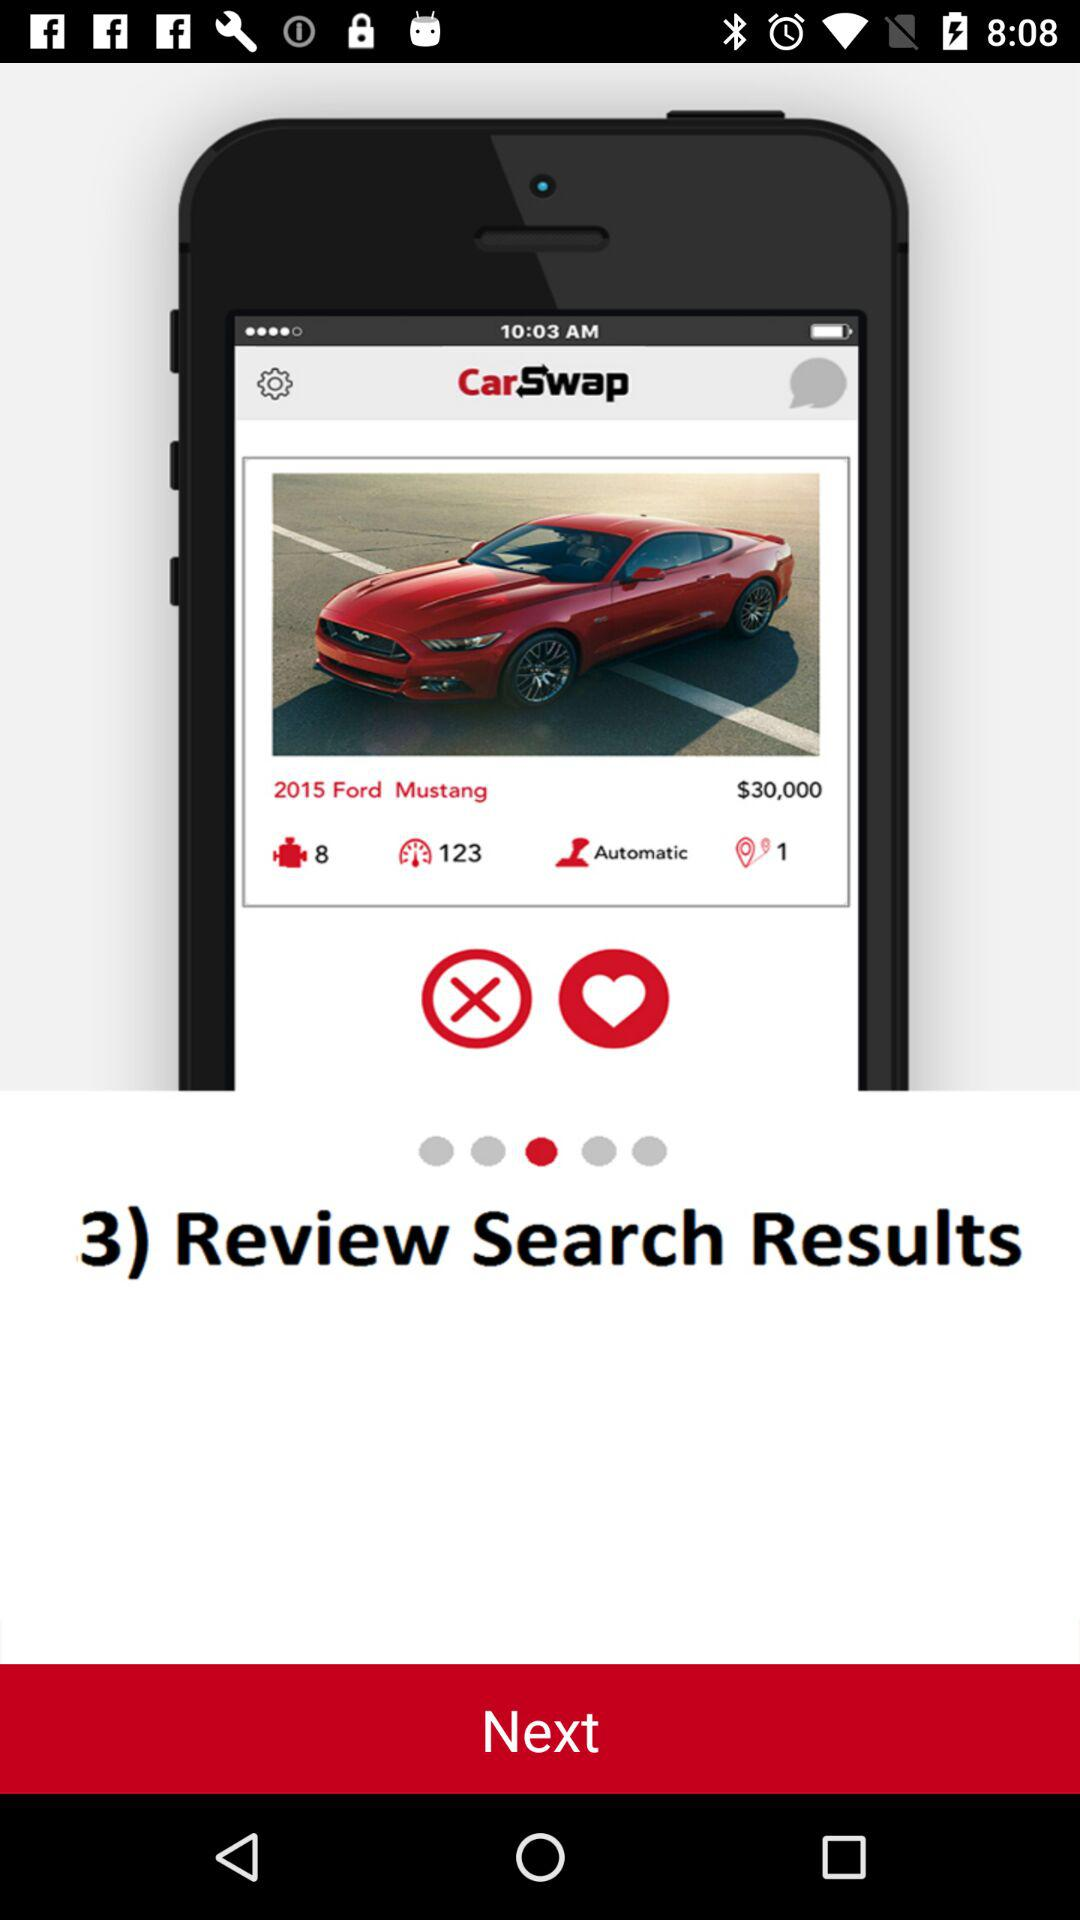How many results are shown in the search results?
Answer the question using a single word or phrase. 3 